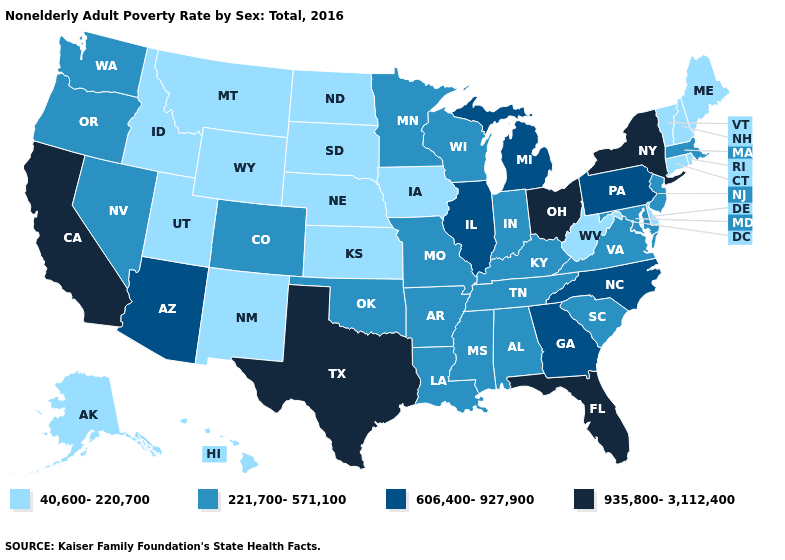Name the states that have a value in the range 40,600-220,700?
Short answer required. Alaska, Connecticut, Delaware, Hawaii, Idaho, Iowa, Kansas, Maine, Montana, Nebraska, New Hampshire, New Mexico, North Dakota, Rhode Island, South Dakota, Utah, Vermont, West Virginia, Wyoming. What is the highest value in states that border Montana?
Short answer required. 40,600-220,700. Name the states that have a value in the range 40,600-220,700?
Concise answer only. Alaska, Connecticut, Delaware, Hawaii, Idaho, Iowa, Kansas, Maine, Montana, Nebraska, New Hampshire, New Mexico, North Dakota, Rhode Island, South Dakota, Utah, Vermont, West Virginia, Wyoming. Does the map have missing data?
Keep it brief. No. What is the value of Delaware?
Be succinct. 40,600-220,700. Which states have the highest value in the USA?
Be succinct. California, Florida, New York, Ohio, Texas. What is the value of Missouri?
Quick response, please. 221,700-571,100. Does Utah have a lower value than Delaware?
Concise answer only. No. Which states have the highest value in the USA?
Be succinct. California, Florida, New York, Ohio, Texas. Name the states that have a value in the range 40,600-220,700?
Short answer required. Alaska, Connecticut, Delaware, Hawaii, Idaho, Iowa, Kansas, Maine, Montana, Nebraska, New Hampshire, New Mexico, North Dakota, Rhode Island, South Dakota, Utah, Vermont, West Virginia, Wyoming. Does Nebraska have a lower value than Alaska?
Give a very brief answer. No. What is the value of Hawaii?
Quick response, please. 40,600-220,700. Name the states that have a value in the range 935,800-3,112,400?
Concise answer only. California, Florida, New York, Ohio, Texas. Name the states that have a value in the range 935,800-3,112,400?
Short answer required. California, Florida, New York, Ohio, Texas. Does Colorado have the lowest value in the USA?
Answer briefly. No. 